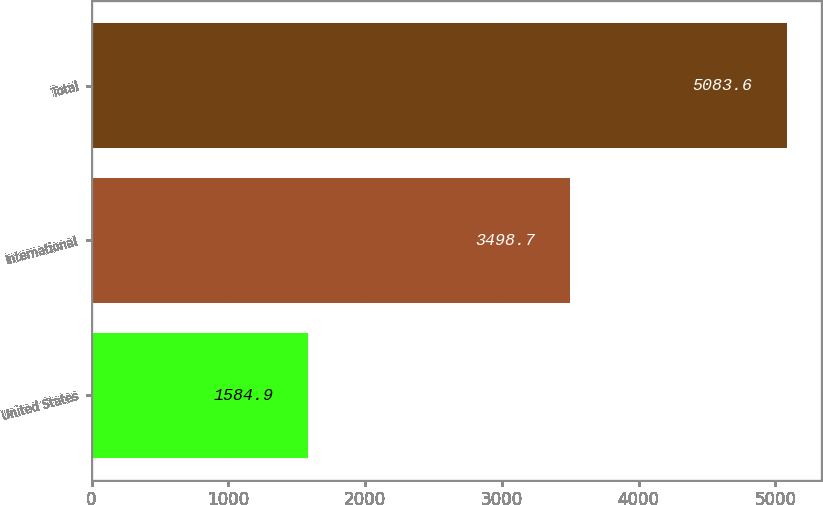<chart> <loc_0><loc_0><loc_500><loc_500><bar_chart><fcel>United States<fcel>International<fcel>Total<nl><fcel>1584.9<fcel>3498.7<fcel>5083.6<nl></chart> 